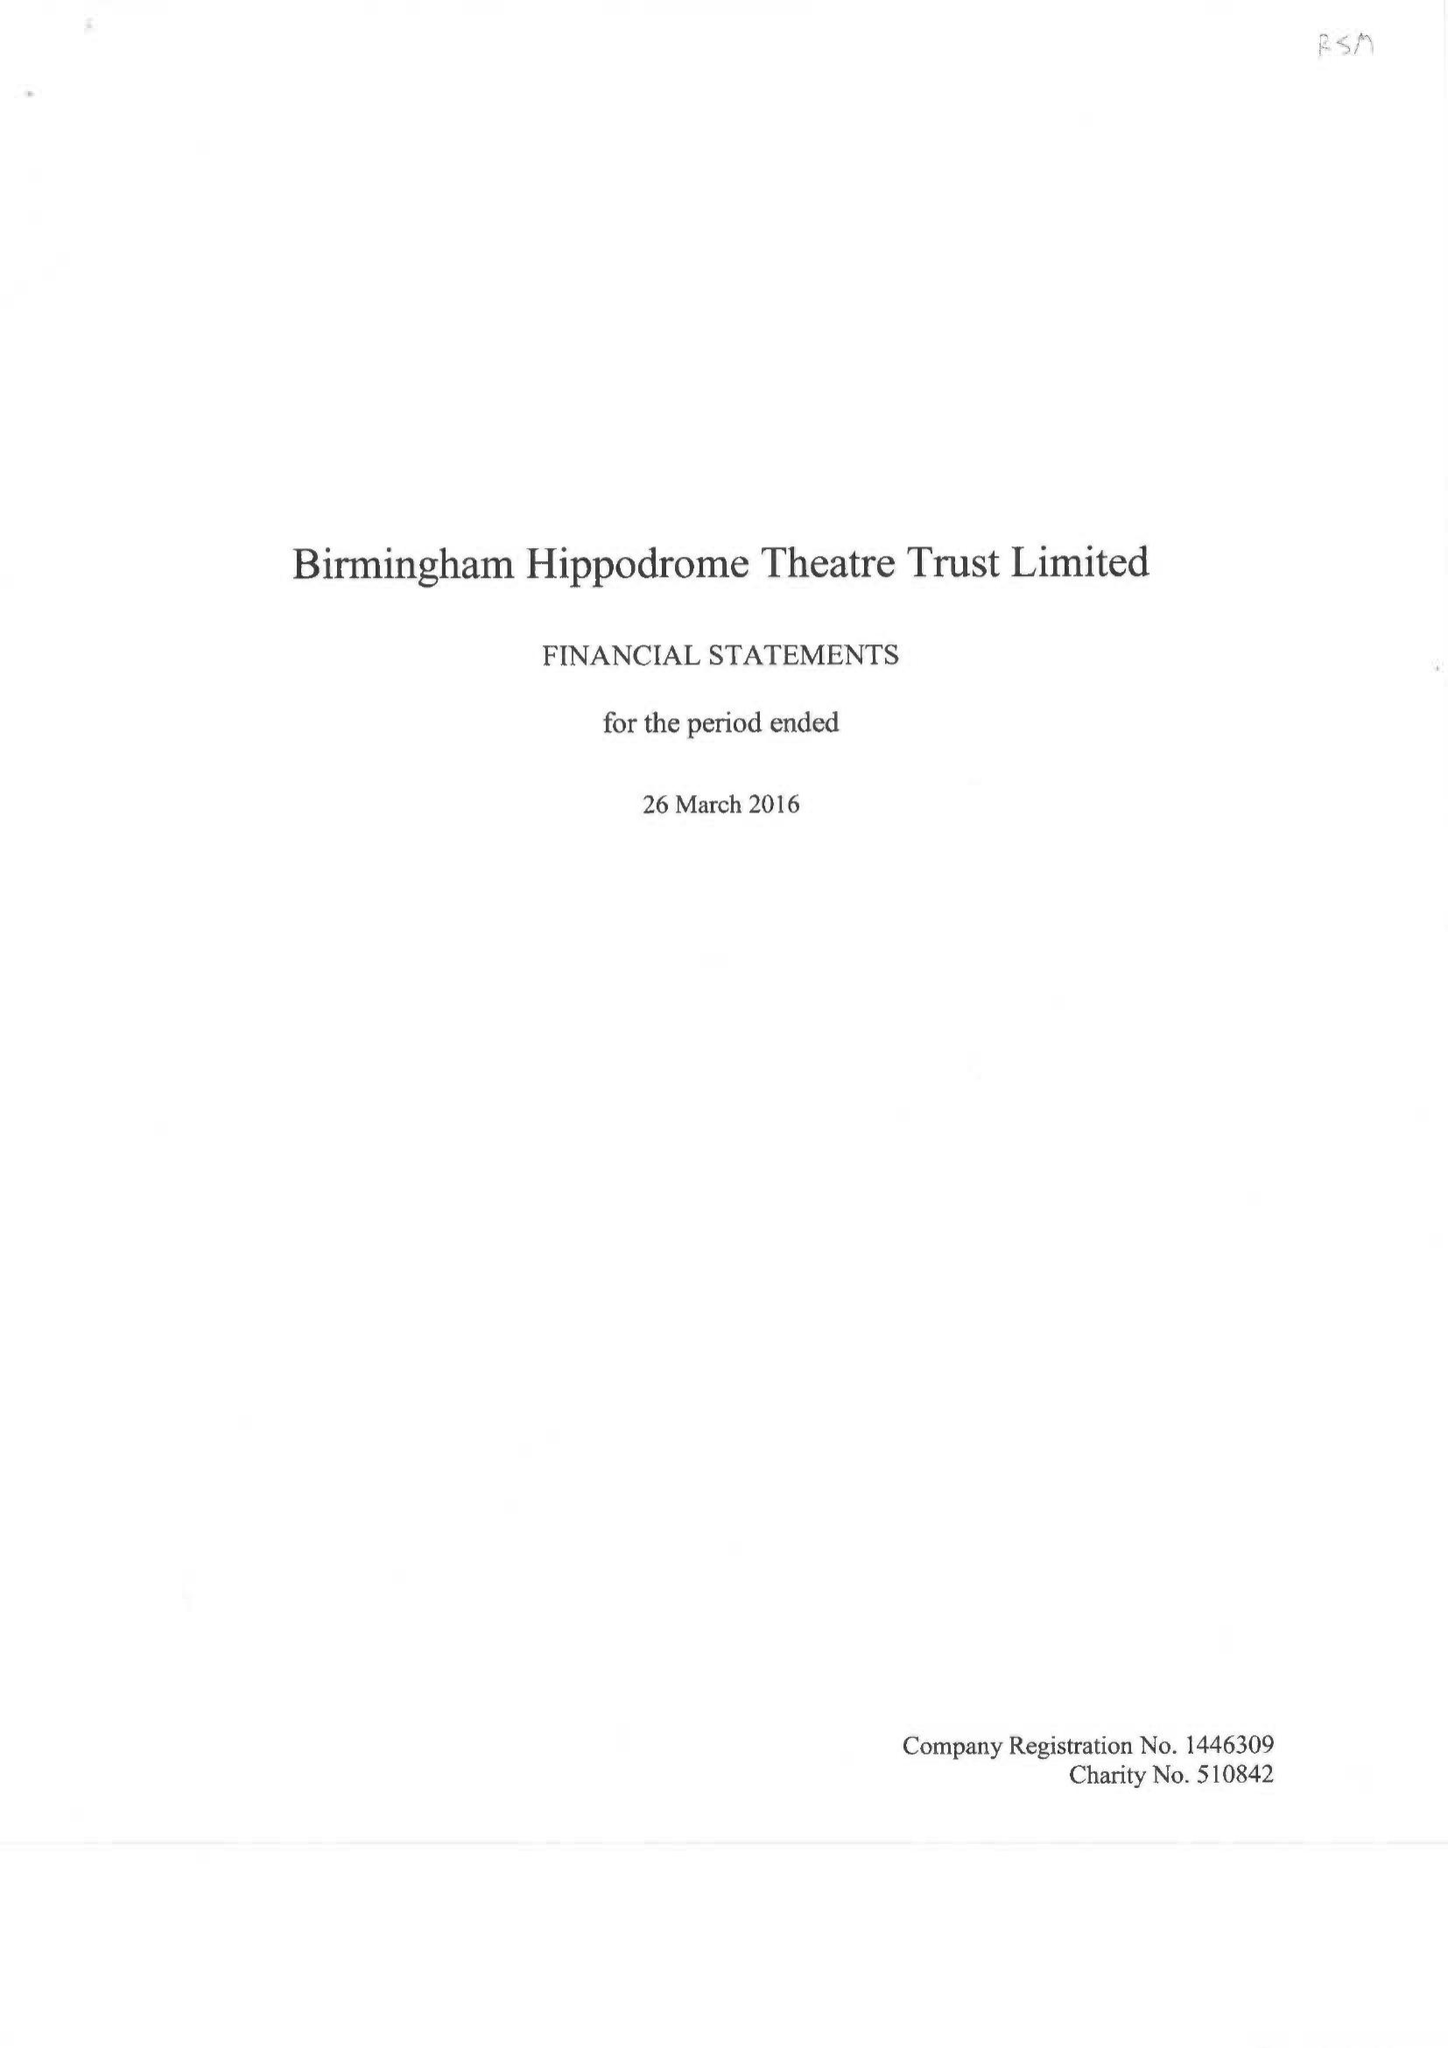What is the value for the address__post_town?
Answer the question using a single word or phrase. BIRMINGHAM 